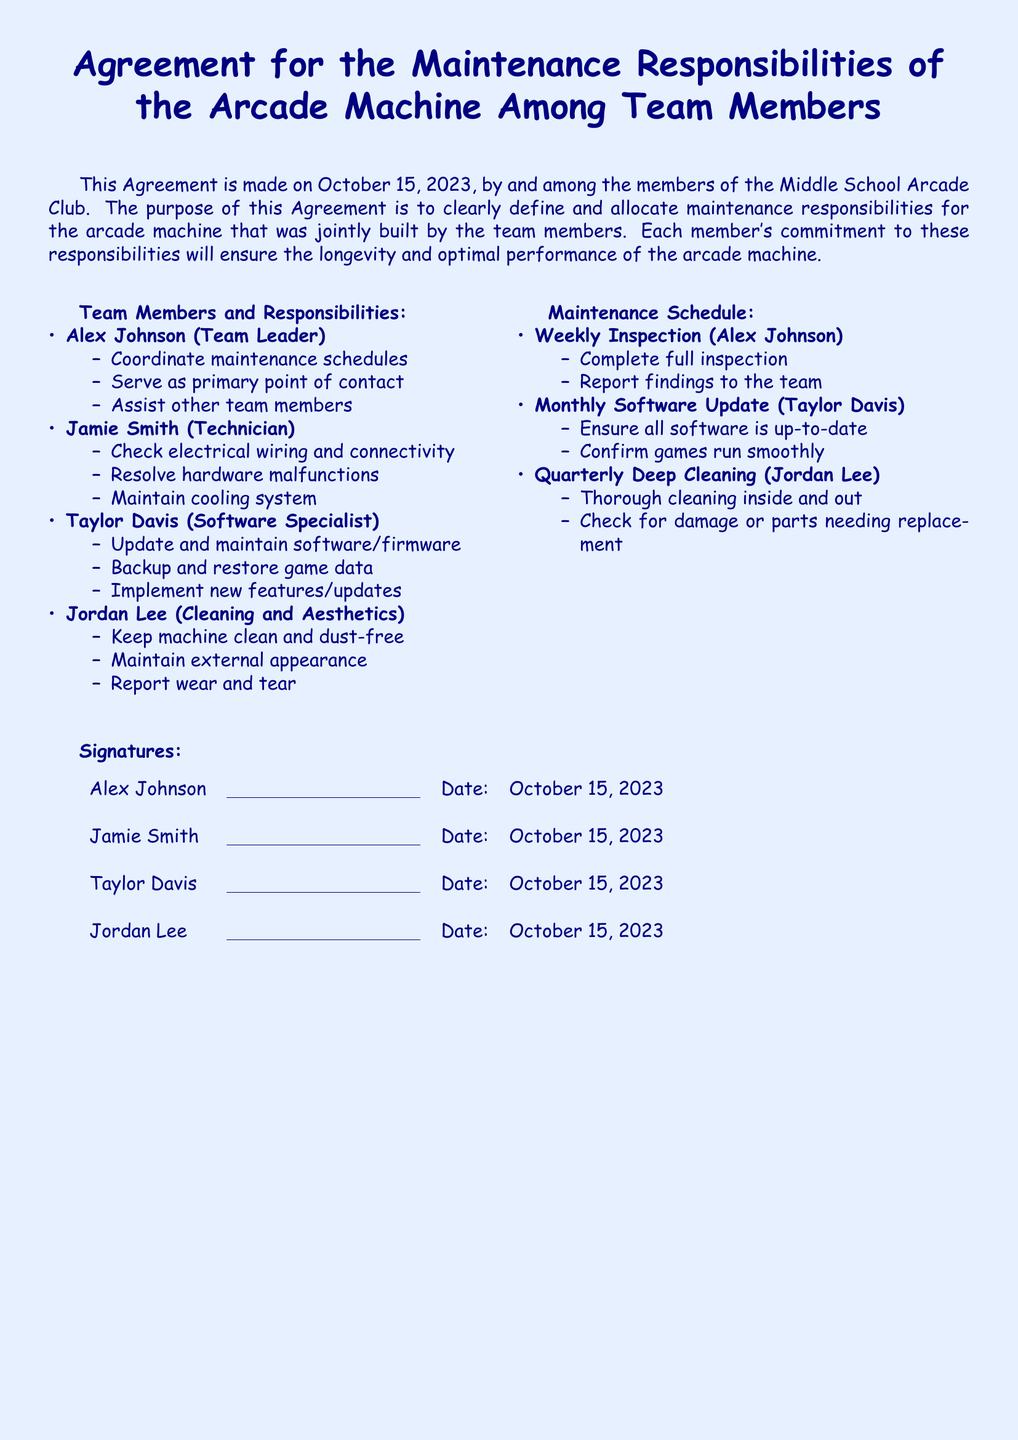What is the date of the agreement? The date of the agreement is stated clearly at the beginning of the document.
Answer: October 15, 2023 Who is the team leader? The team leader's name is listed in the document under team members and their responsibilities.
Answer: Alex Johnson What is Jamie Smith's role? Jamie Smith's role is defined under the section that specifies team members and their responsibilities.
Answer: Technician How often is the software updated? The frequency of the software update is specified in the maintenance schedule section.
Answer: Monthly What is Jordan Lee responsible for? Jordan Lee's responsibilities are outlined clearly, including tasks related to maintenance and aesthetics.
Answer: Cleaning and Aesthetics When is the quarterly deep cleaning scheduled? The quarterly deep cleaning is mentioned in the maintenance schedule, which details the timing.
Answer: Quarterly Who assists other team members? The specific responsibilities of team members are listed, highlighting who assists others.
Answer: Alex Johnson What must Taylor Davis ensure with the software? The document explains Taylor Davis's responsibilities regarding the software in the maintenance schedule.
Answer: Up-to-date 